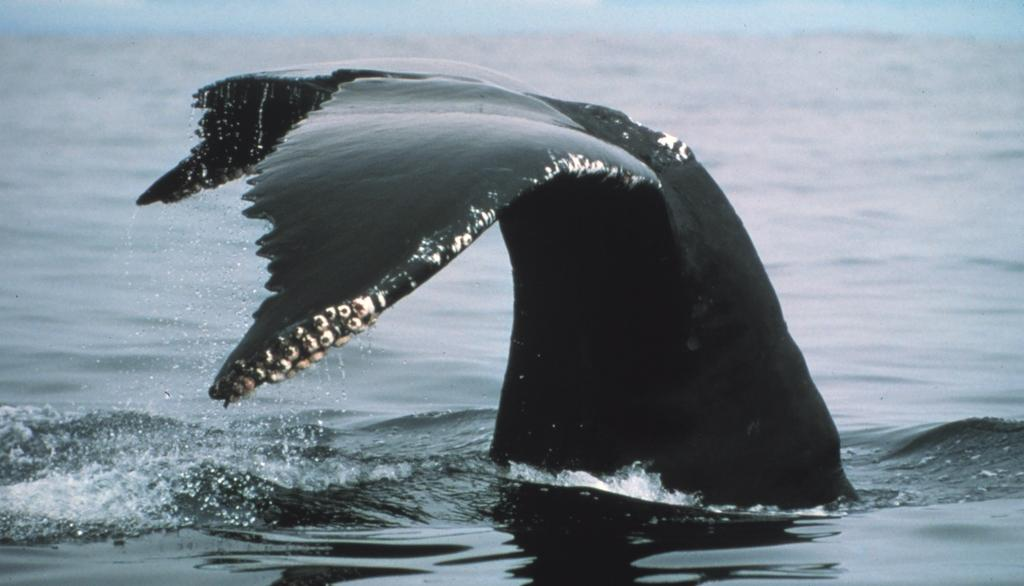What type of animal is in the image? There is an animal in the image, but its specific type cannot be determined from the provided facts. What colors are present on the animal in the image? The animal is black and white in color. Where is the animal located in the image? The animal is in the water. What can be seen in the background of the image? There is water and the sky visible in the background of the image. What type of paper is being used by the animal to fly in the image? There is no paper or indication of flying in the image; it features an animal in the water. Can you see the animal's hand in the image? Animals do not have hands, and there is no mention of a hand in the image. 